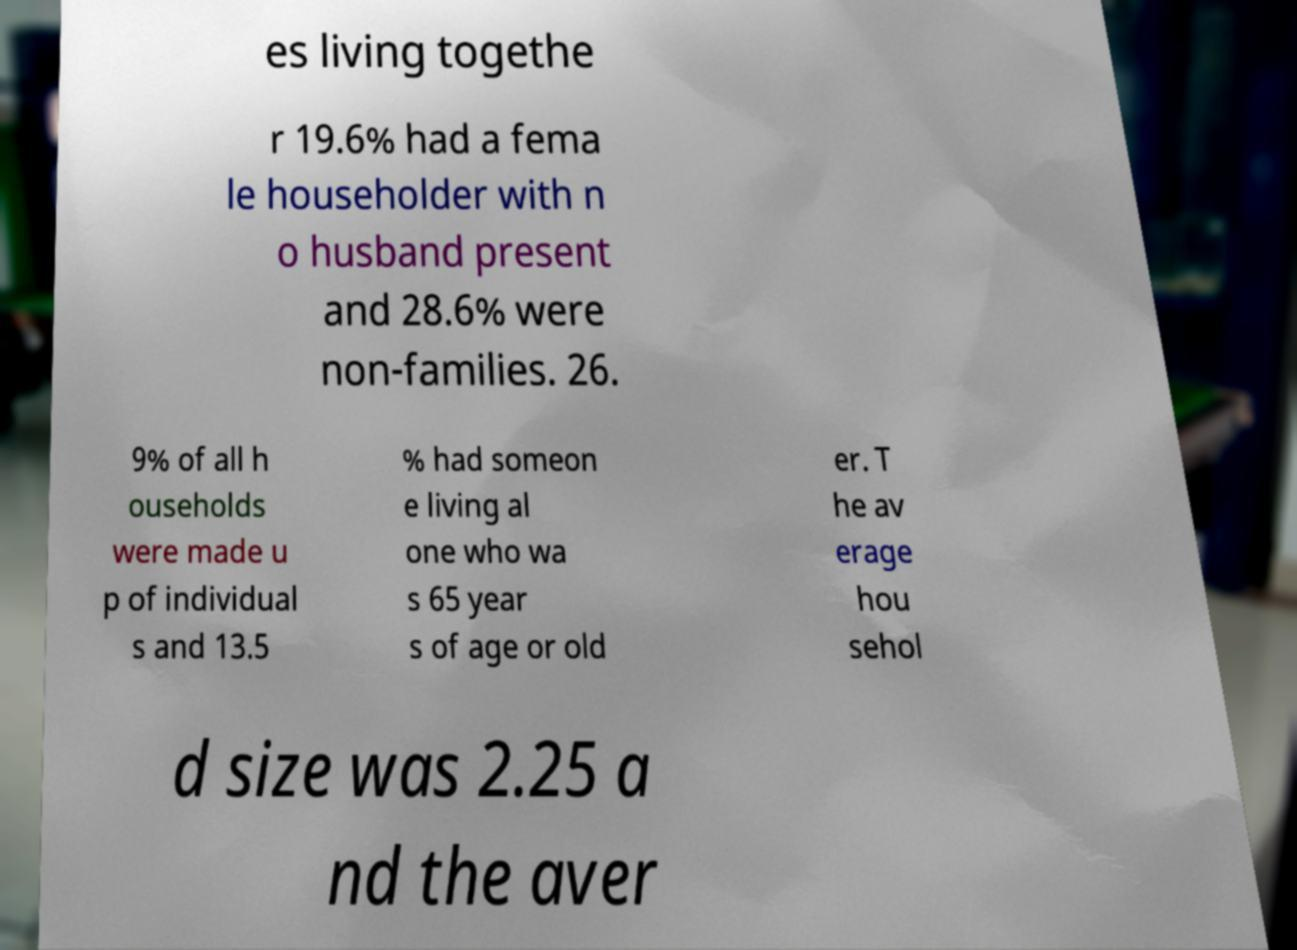Can you read and provide the text displayed in the image?This photo seems to have some interesting text. Can you extract and type it out for me? es living togethe r 19.6% had a fema le householder with n o husband present and 28.6% were non-families. 26. 9% of all h ouseholds were made u p of individual s and 13.5 % had someon e living al one who wa s 65 year s of age or old er. T he av erage hou sehol d size was 2.25 a nd the aver 